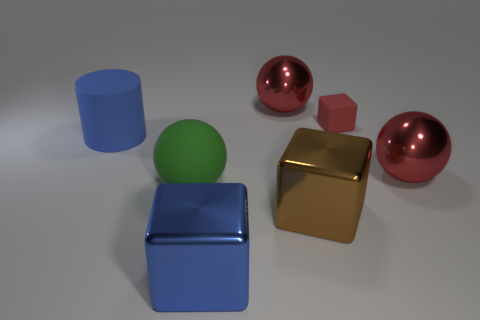Subtract all small matte blocks. How many blocks are left? 2 Add 3 tiny gray rubber blocks. How many objects exist? 10 Subtract all green balls. How many balls are left? 2 Subtract 2 balls. How many balls are left? 1 Subtract all cylinders. How many objects are left? 6 Subtract all tiny cyan cylinders. Subtract all blue things. How many objects are left? 5 Add 6 small things. How many small things are left? 7 Add 2 green metal blocks. How many green metal blocks exist? 2 Subtract 1 blue cylinders. How many objects are left? 6 Subtract all cyan spheres. Subtract all brown cylinders. How many spheres are left? 3 